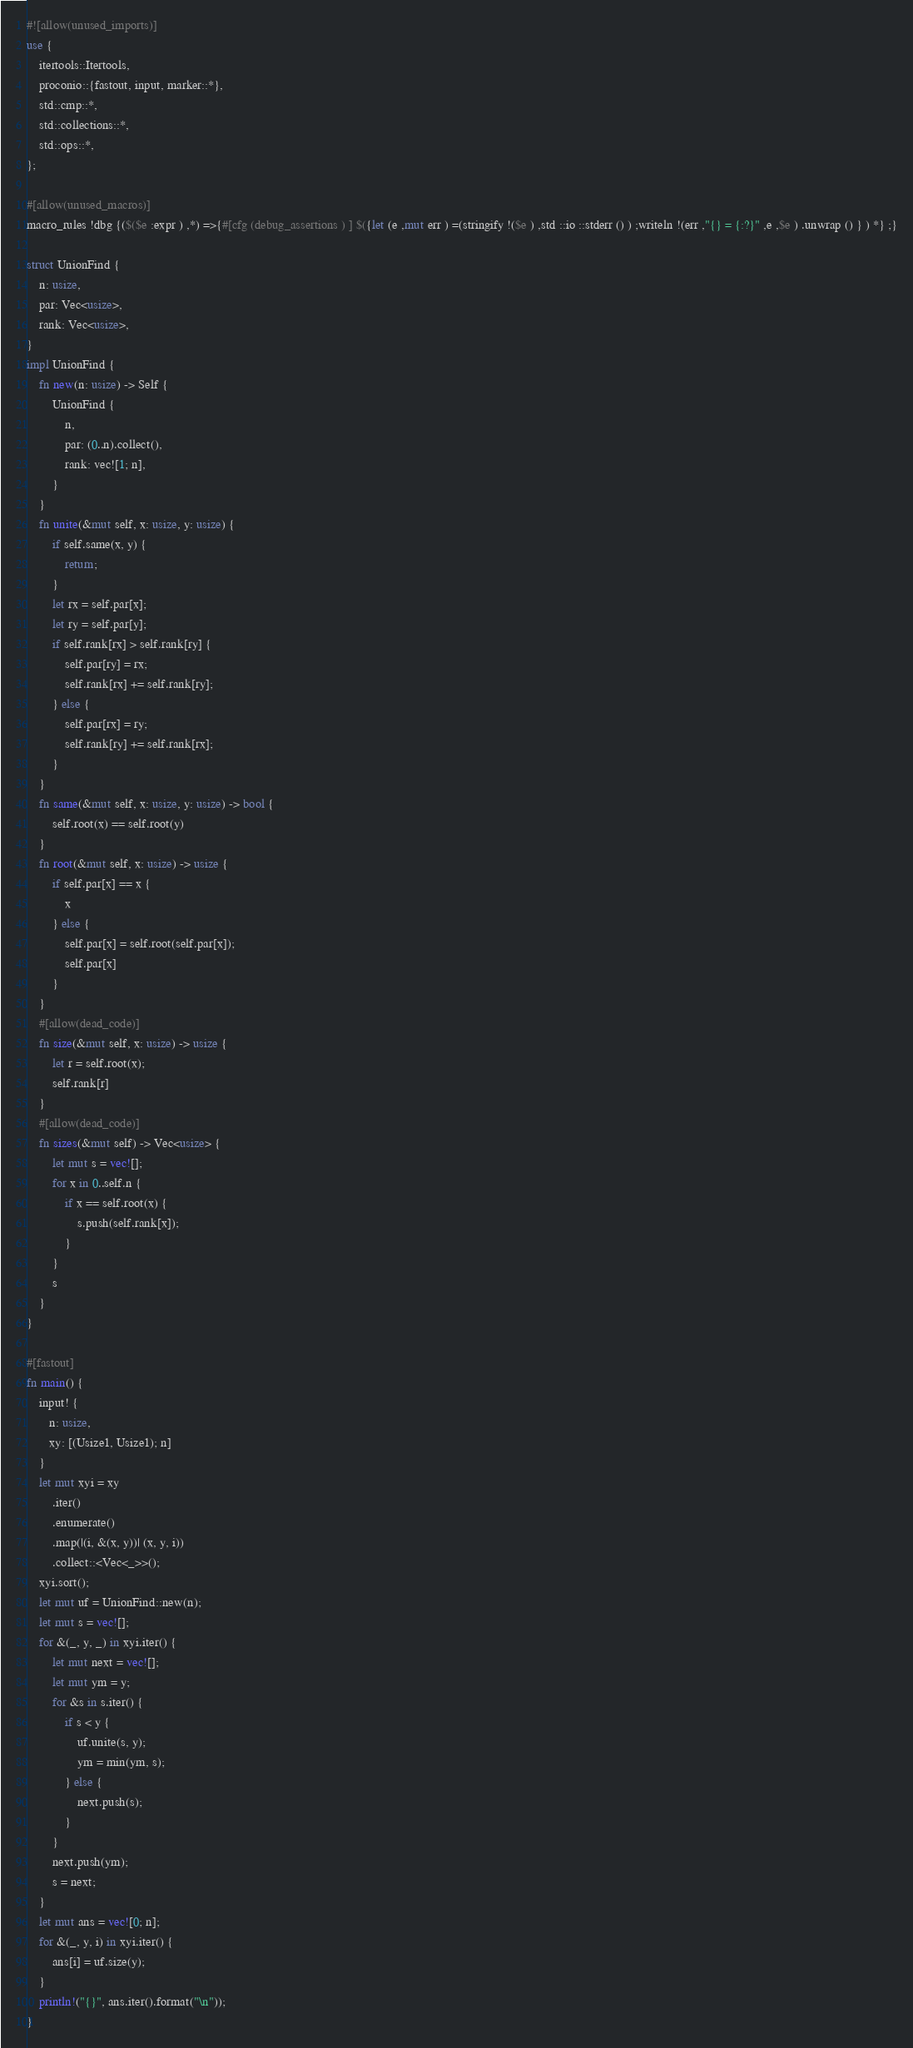<code> <loc_0><loc_0><loc_500><loc_500><_Rust_>#![allow(unused_imports)]
use {
    itertools::Itertools,
    proconio::{fastout, input, marker::*},
    std::cmp::*,
    std::collections::*,
    std::ops::*,
};

#[allow(unused_macros)]
macro_rules !dbg {($($e :expr ) ,*) =>{#[cfg (debug_assertions ) ] $({let (e ,mut err ) =(stringify !($e ) ,std ::io ::stderr () ) ;writeln !(err ,"{} = {:?}" ,e ,$e ) .unwrap () } ) *} ;}

struct UnionFind {
    n: usize,
    par: Vec<usize>,
    rank: Vec<usize>,
}
impl UnionFind {
    fn new(n: usize) -> Self {
        UnionFind {
            n,
            par: (0..n).collect(),
            rank: vec![1; n],
        }
    }
    fn unite(&mut self, x: usize, y: usize) {
        if self.same(x, y) {
            return;
        }
        let rx = self.par[x];
        let ry = self.par[y];
        if self.rank[rx] > self.rank[ry] {
            self.par[ry] = rx;
            self.rank[rx] += self.rank[ry];
        } else {
            self.par[rx] = ry;
            self.rank[ry] += self.rank[rx];
        }
    }
    fn same(&mut self, x: usize, y: usize) -> bool {
        self.root(x) == self.root(y)
    }
    fn root(&mut self, x: usize) -> usize {
        if self.par[x] == x {
            x
        } else {
            self.par[x] = self.root(self.par[x]);
            self.par[x]
        }
    }
    #[allow(dead_code)]
    fn size(&mut self, x: usize) -> usize {
        let r = self.root(x);
        self.rank[r]
    }
    #[allow(dead_code)]
    fn sizes(&mut self) -> Vec<usize> {
        let mut s = vec![];
        for x in 0..self.n {
            if x == self.root(x) {
                s.push(self.rank[x]);
            }
        }
        s
    }
}

#[fastout]
fn main() {
    input! {
       n: usize,
       xy: [(Usize1, Usize1); n]
    }
    let mut xyi = xy
        .iter()
        .enumerate()
        .map(|(i, &(x, y))| (x, y, i))
        .collect::<Vec<_>>();
    xyi.sort();
    let mut uf = UnionFind::new(n);
    let mut s = vec![];
    for &(_, y, _) in xyi.iter() {
        let mut next = vec![];
        let mut ym = y;
        for &s in s.iter() {
            if s < y {
                uf.unite(s, y);
                ym = min(ym, s);
            } else {
                next.push(s);
            }
        }
        next.push(ym);
        s = next;
    }
    let mut ans = vec![0; n];
    for &(_, y, i) in xyi.iter() {
        ans[i] = uf.size(y);
    }
    println!("{}", ans.iter().format("\n"));
}
</code> 